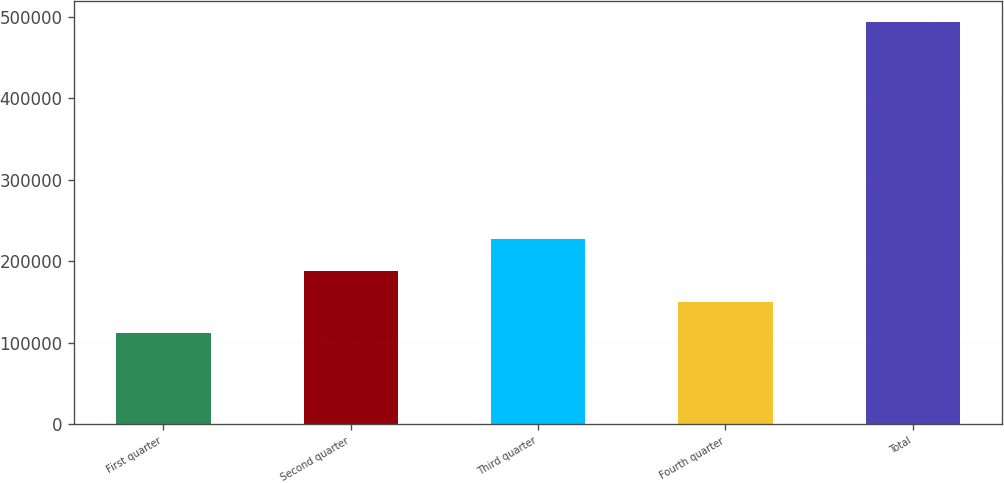Convert chart to OTSL. <chart><loc_0><loc_0><loc_500><loc_500><bar_chart><fcel>First quarter<fcel>Second quarter<fcel>Third quarter<fcel>Fourth quarter<fcel>Total<nl><fcel>111931<fcel>188375<fcel>226597<fcel>150153<fcel>494150<nl></chart> 